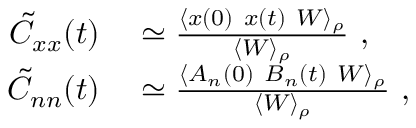<formula> <loc_0><loc_0><loc_500><loc_500>\begin{array} { r l } { \tilde { C } _ { x x } ( t ) } & \simeq \frac { \langle x ( 0 ) \ x ( t ) \ W \rangle _ { \rho } } { \langle W \rangle _ { \rho } } , } \\ { \tilde { C } _ { n n } ( t ) } & \simeq \frac { \langle A _ { n } ( 0 ) \ B _ { n } ( t ) \ W \rangle _ { \rho } } { \langle W \rangle _ { \rho } } , } \end{array}</formula> 